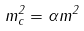Convert formula to latex. <formula><loc_0><loc_0><loc_500><loc_500>m ^ { 2 } _ { c } = \alpha m ^ { 2 }</formula> 